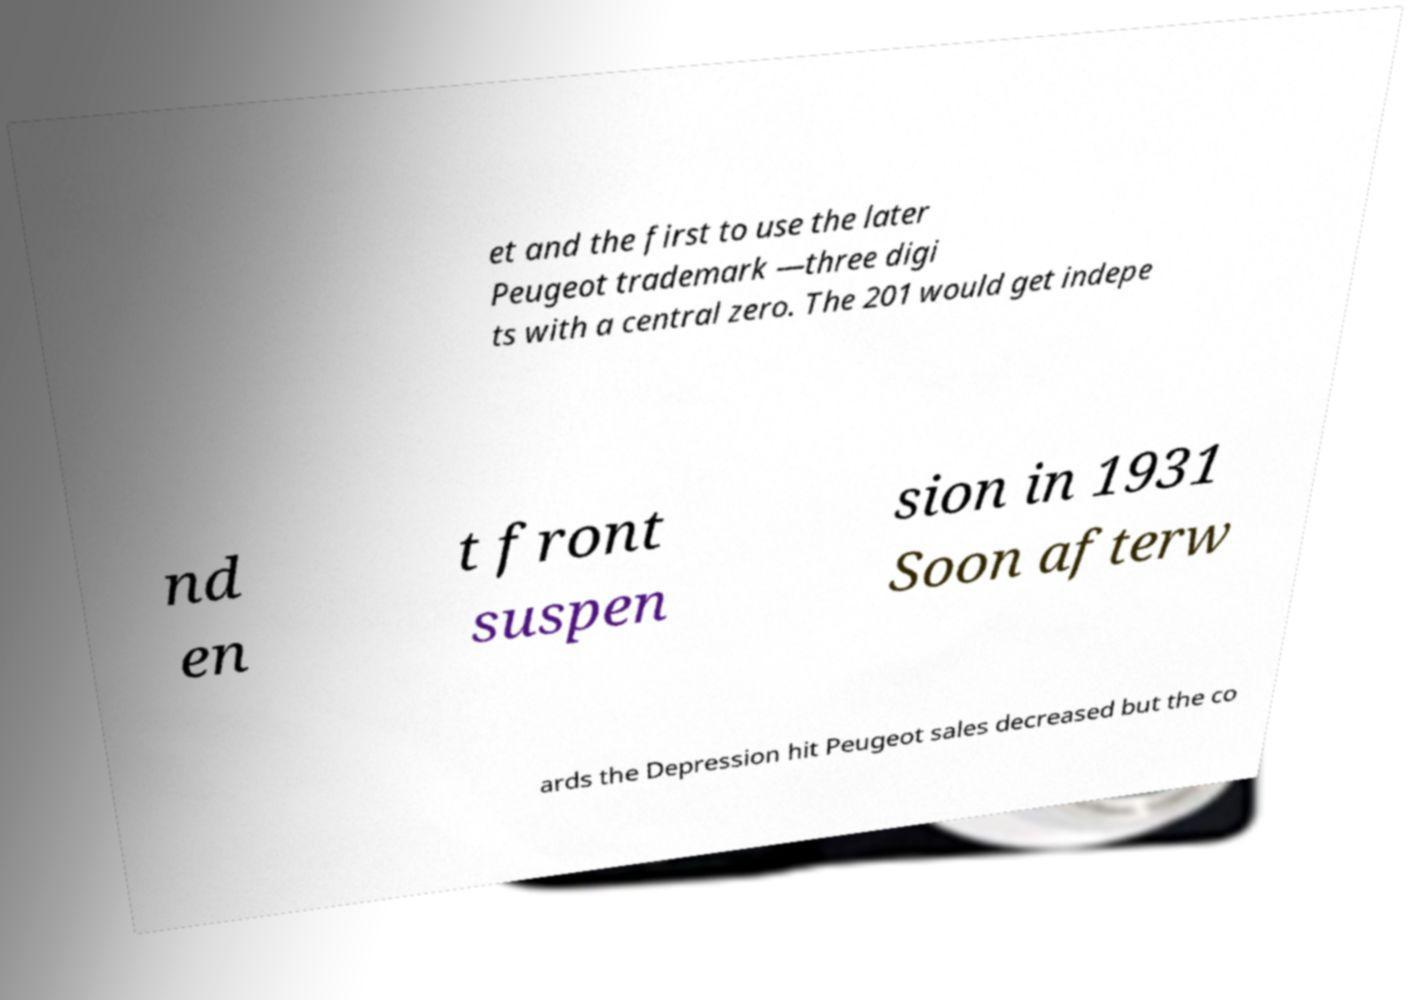For documentation purposes, I need the text within this image transcribed. Could you provide that? et and the first to use the later Peugeot trademark —three digi ts with a central zero. The 201 would get indepe nd en t front suspen sion in 1931 Soon afterw ards the Depression hit Peugeot sales decreased but the co 